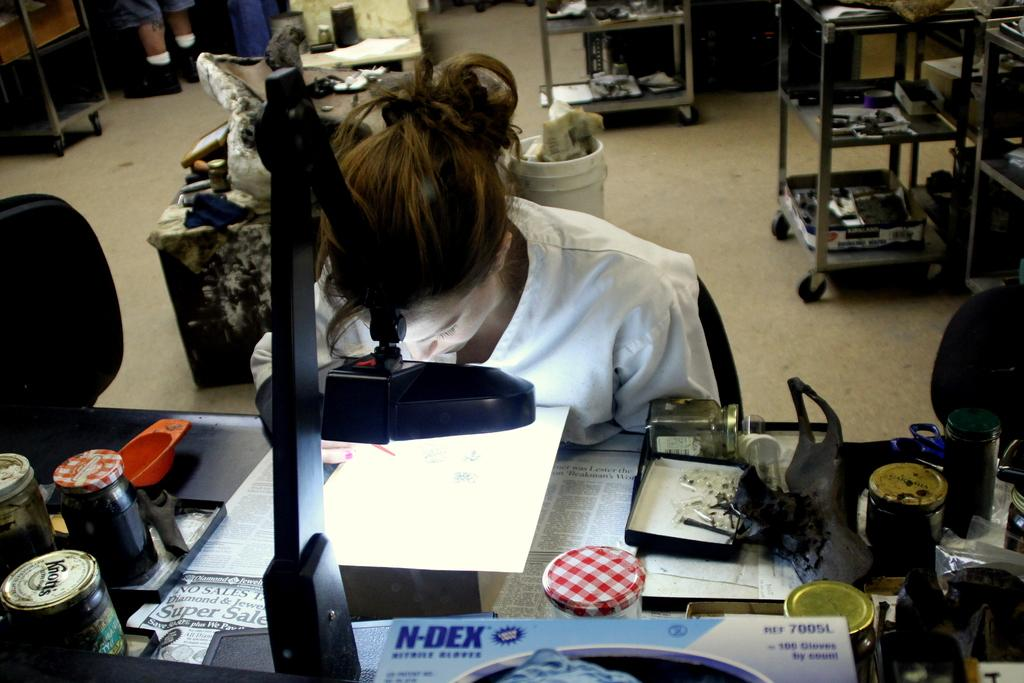<image>
Create a compact narrative representing the image presented. A box that says "N-DEX" is on a desk that a girl is sitting at. 